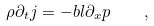Convert formula to latex. <formula><loc_0><loc_0><loc_500><loc_500>\rho \partial _ { t } j = - b l \partial _ { x } p \quad ,</formula> 